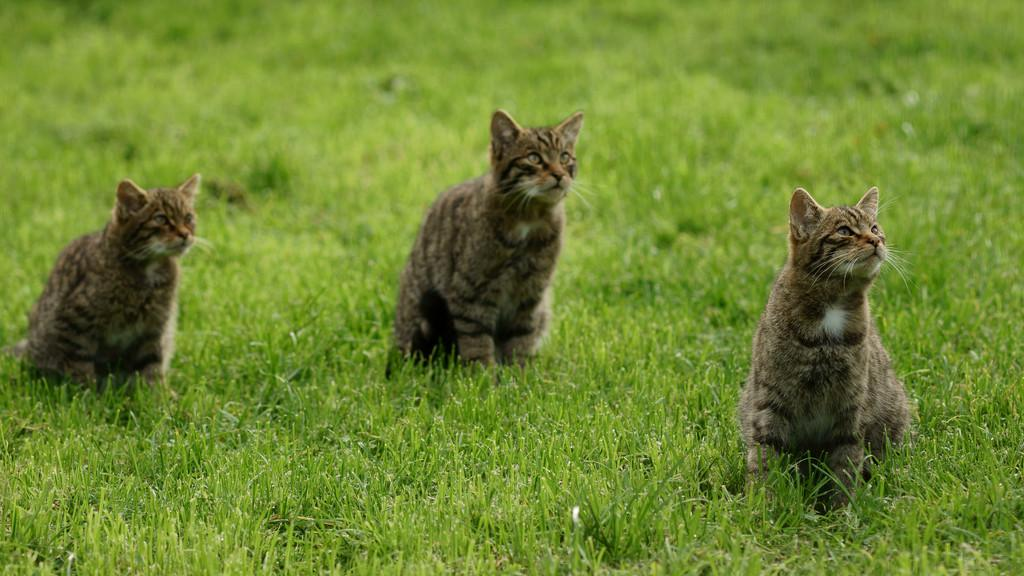How many cats are present in the image? There are three cats in the image. What are the cats doing in the image? The cats are sitting on the grass. What type of art is the cats creating in the image? There is no indication in the image that the cats are creating any art. 